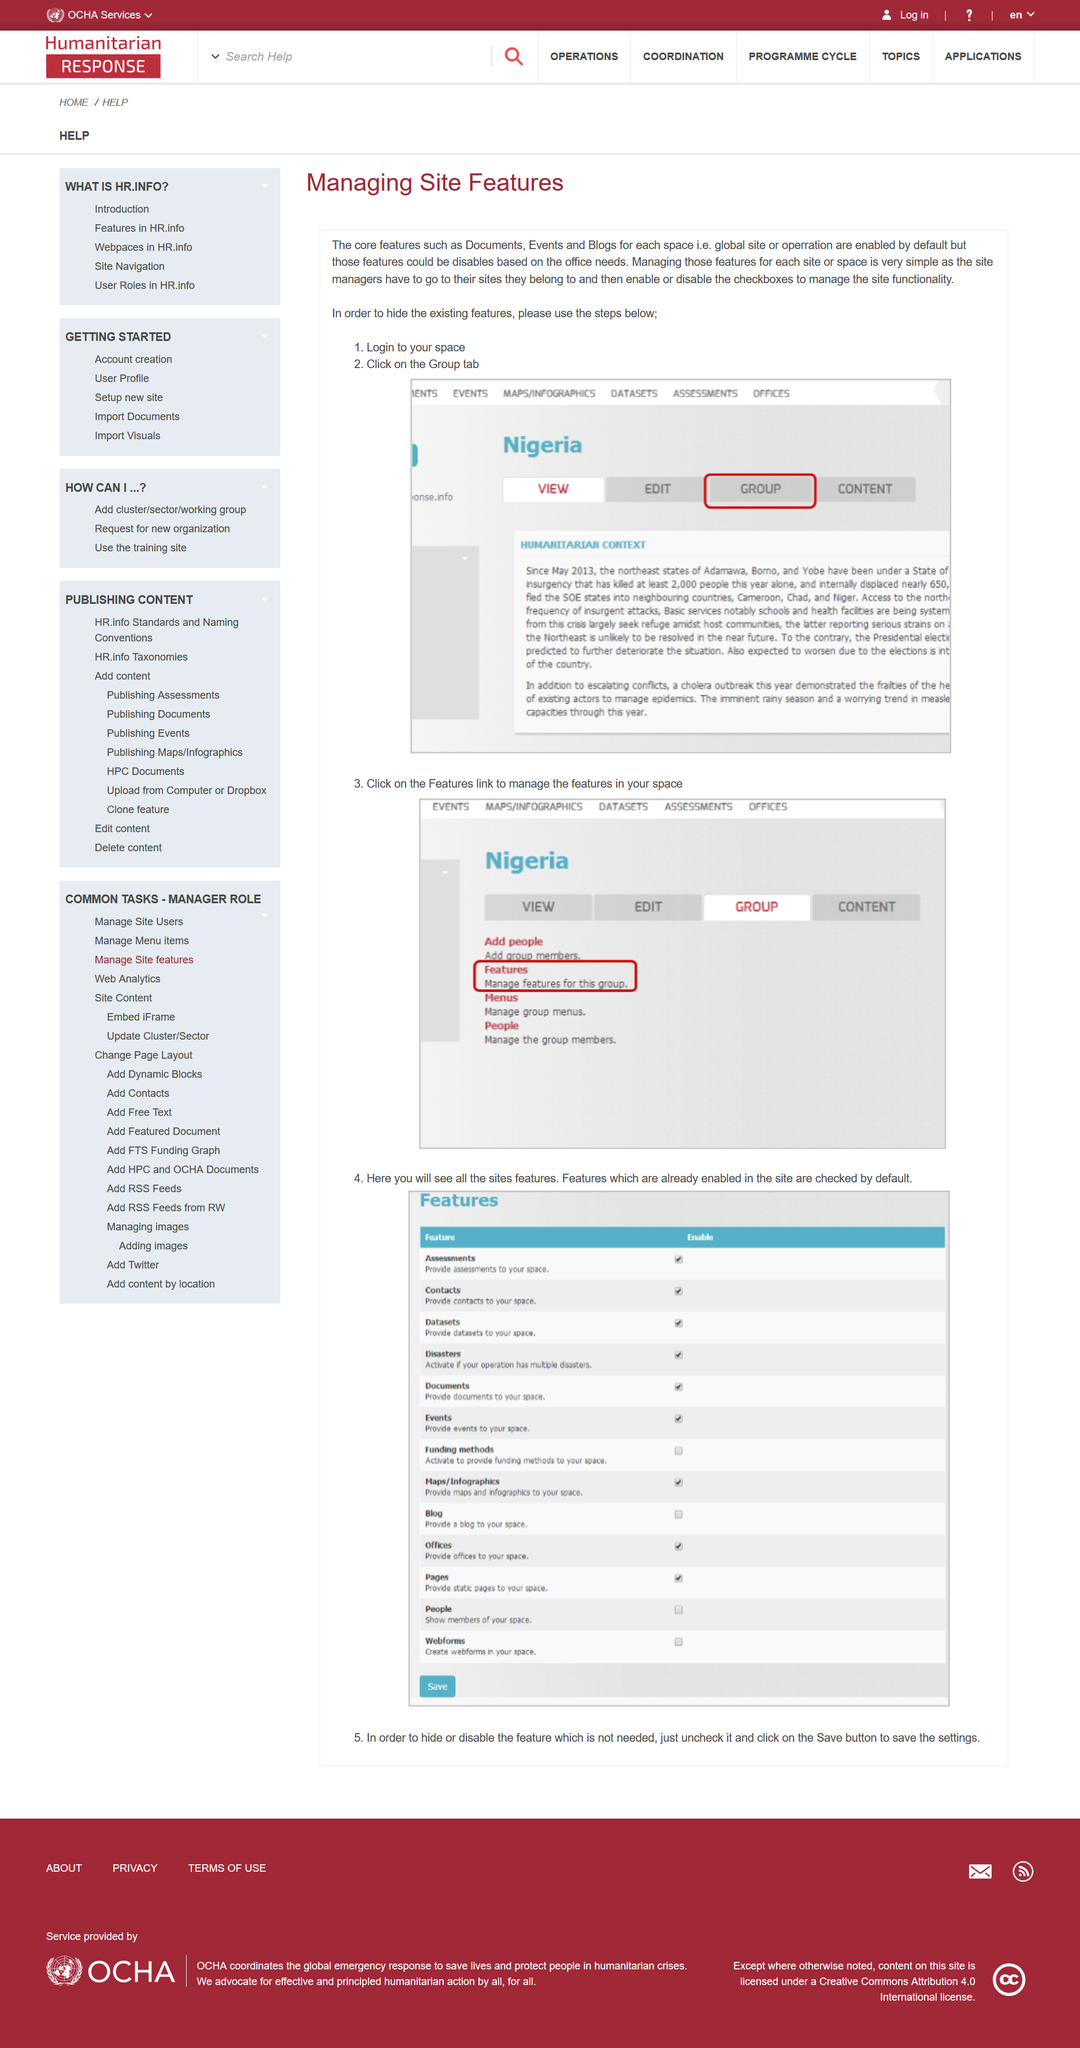Give some essential details in this illustration. Yes, Documents is a core feature of each space. Yes, Events is considered a core feature of each Space. Clicking on the Group tab is one of the steps involved in hiding existing features. 